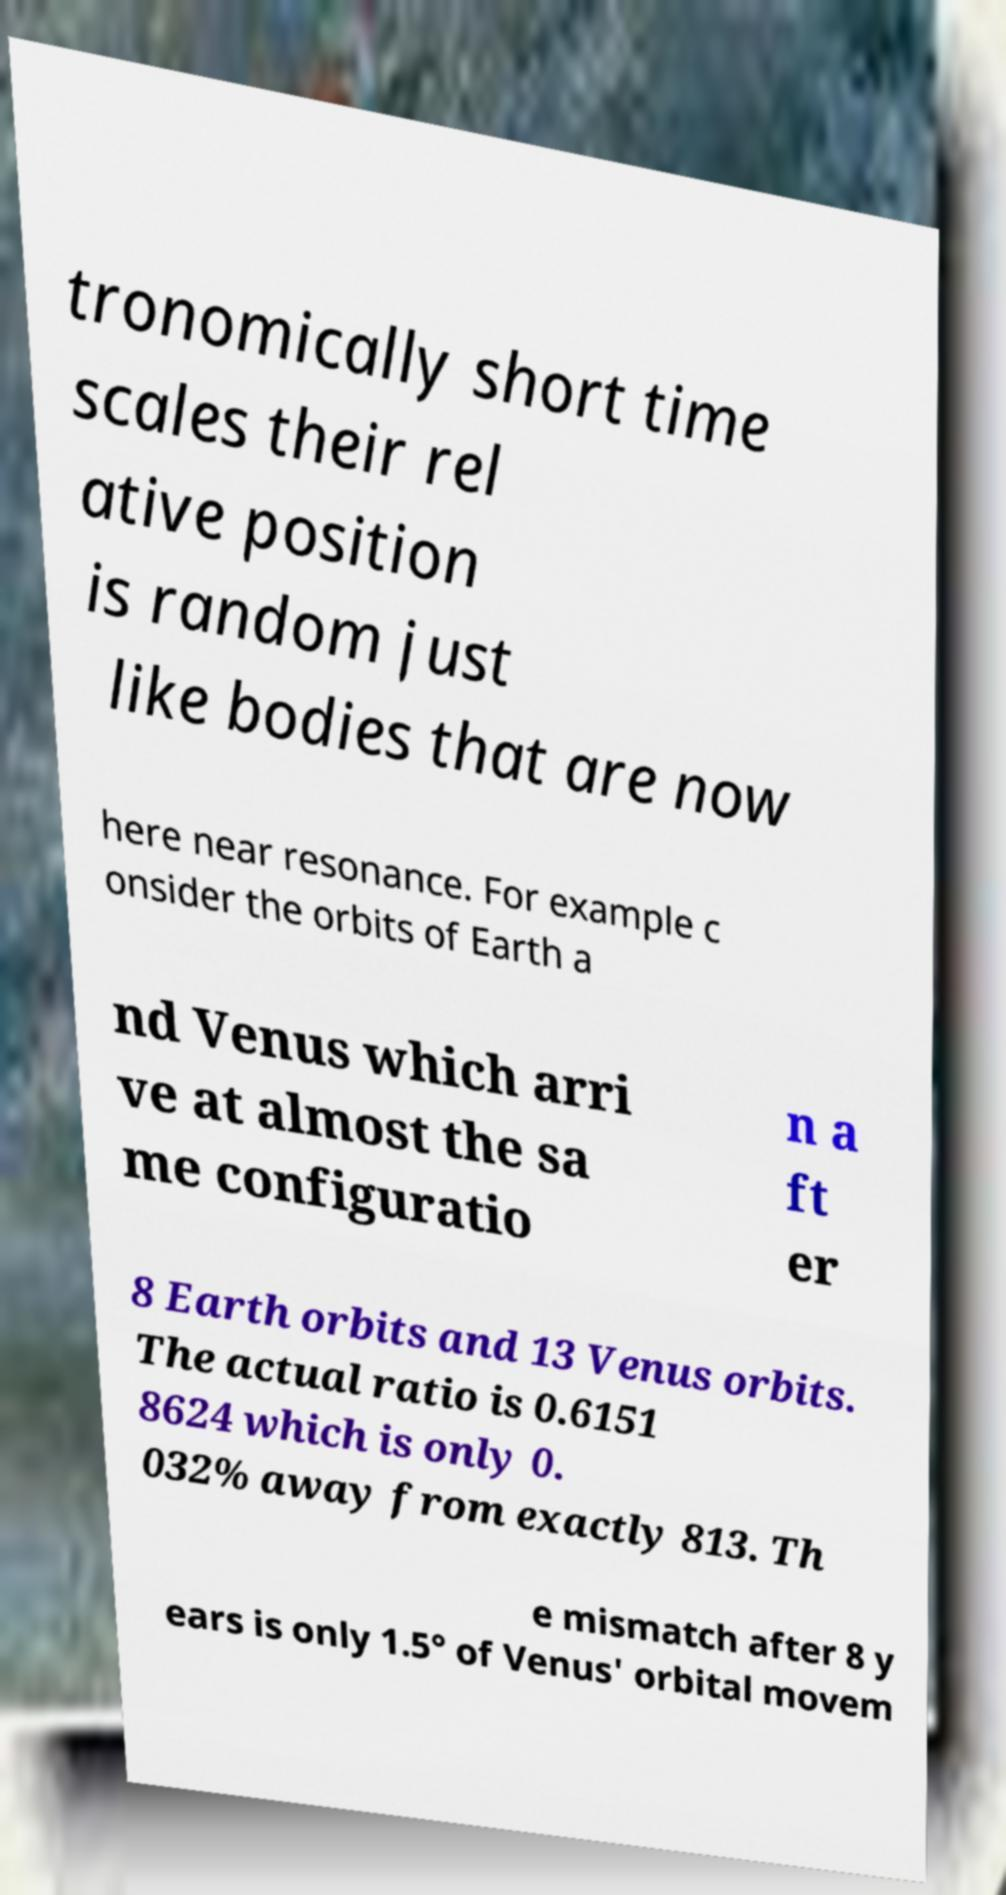Please identify and transcribe the text found in this image. tronomically short time scales their rel ative position is random just like bodies that are now here near resonance. For example c onsider the orbits of Earth a nd Venus which arri ve at almost the sa me configuratio n a ft er 8 Earth orbits and 13 Venus orbits. The actual ratio is 0.6151 8624 which is only 0. 032% away from exactly 813. Th e mismatch after 8 y ears is only 1.5° of Venus' orbital movem 